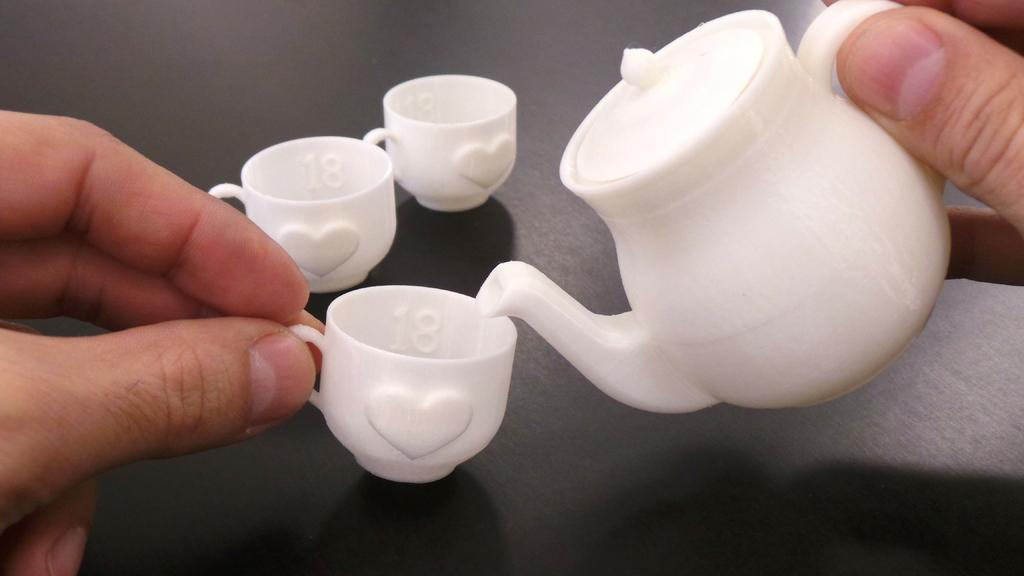What is the person in the image holding? The person is holding a cup in the image. What other object related to serving beverages can be seen in the image? There is a teapot in the image. Can you describe the surface where the cups are placed? The cups are placed on a black surface in the image. What color are the cups? The cups are white in color. How does the person in the image show respect to the cups? The image does not show any indication of the person showing respect to the cups. 